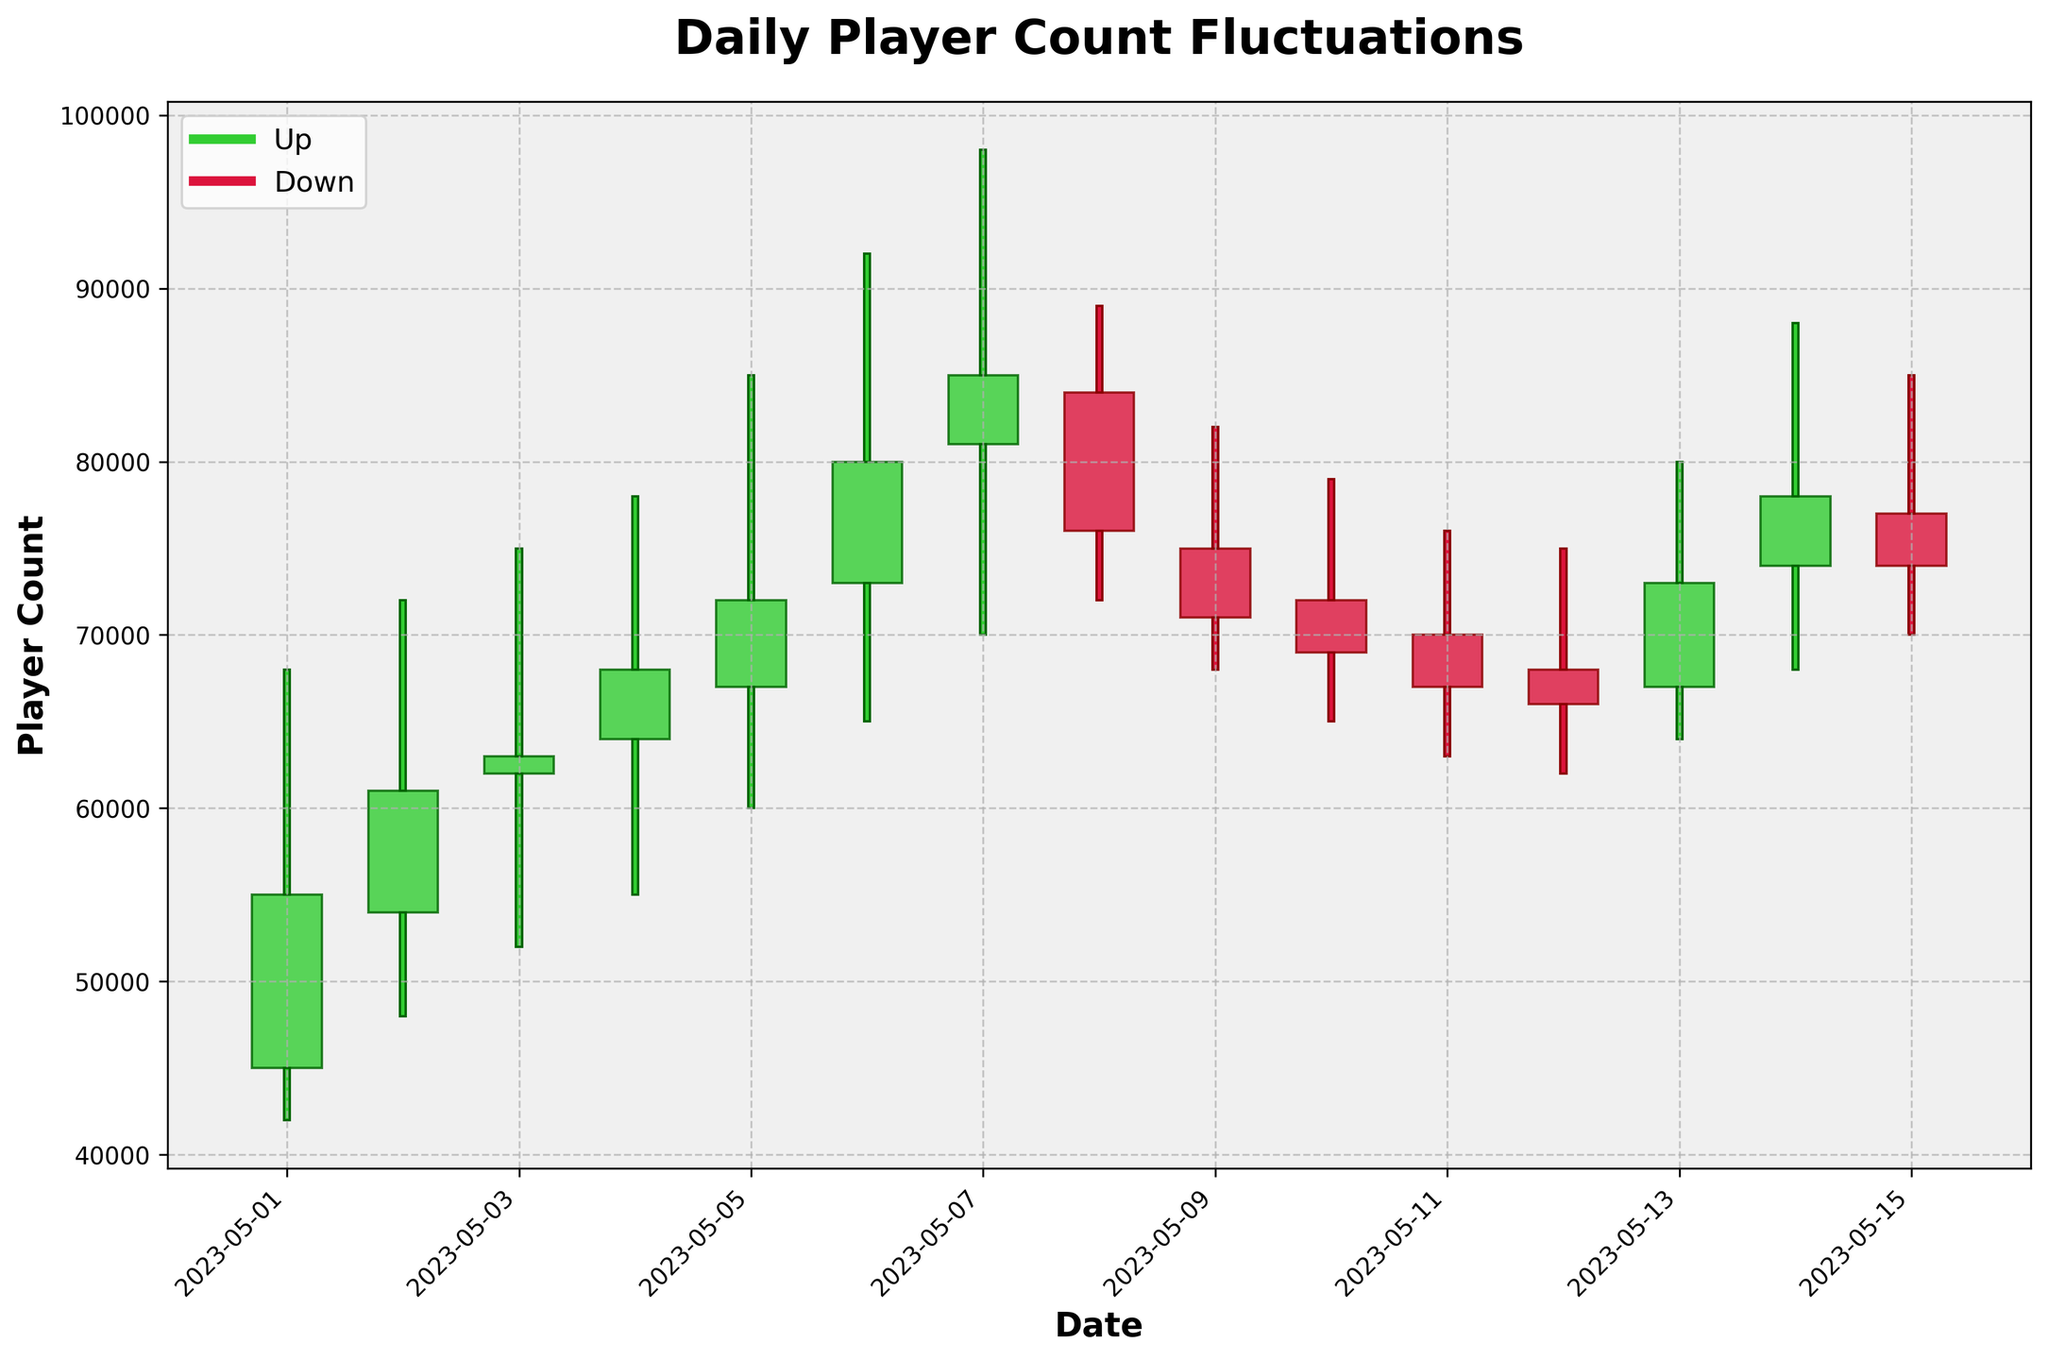What's the title of the figure? The title is clearly displayed at the top of the plot. It helps set the context and informs the viewer about the data being showcased.
Answer: Daily Player Count Fluctuations What is the color used to represent 'Up' days? The legend indicates the colors representing 'Up' and 'Down' days. The 'Up' days are shown in lime green.
Answer: lime green On which dates did the player count close higher than the open? To find this, look for the dates where the bars are colored lime green. There are multiple such dates visible (e.g., May 1, May 2, May 5).
Answer: May 1, May 2, May 3, May 4, May 5, May 6, May 7, May 8, May 9, May 10, May 11, May 12, May 13, May 14, May 15 What is the highest peak player count in the month? This requires identifying the highest value on the 'High' axis across all days. May 7th shows a peak of 98,000, which is the highest.
Answer: 98,000 On which date did the player count have the highest volatility? Volatility can be inferred from the difference between the High and Low values for a single day. The highest difference is on May 7 (98,000 - 70,000 = 28,000).
Answer: May 7 What is the average closing player count for the dates provided? Sum the closing counts for all dates and divide by the number of dates (55000 + 61000 + 63000 + 68000 + 72000 + 80000 + 85000 + 76000 + 71000 + 69000 + 67000 + 66000 + 73000 + 78000 + 74000) / 15
Answer: 70067 Compare the player count trends on May 6 to May 8. What happened? On May 6, the player count opened at 73,000 and closed at 80,000 with a peak at 92,000. On May 7, it continued rising to close at 85,000 with a peak of 98,000. However, on May 8, it dropped significantly to close at 76,000. This suggests a temporary peak followed by a drop.
Answer: Temporary peak Which day saw a drop in player count despite having a higher peak? By comparing the opening and closing values while noting the peak, May 9th opened at 75,000, peaked at 82,000 but closed lower at 71,000.
Answer: May 9 How many days in the period saw more volatility (difference between high and low greater than 20,000)? To answer, calculate the difference between the High and Low values for each date and count those instances where the difference is more than 20,000. High volatility days are May 5 (25,000), May 6 (27,000), May 7 (28,000), May 14 (20,000).
Answer: 4 days 